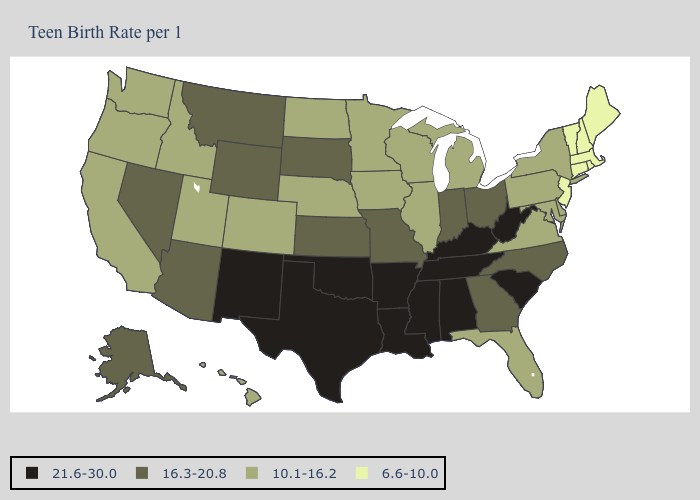What is the highest value in states that border Minnesota?
Answer briefly. 16.3-20.8. What is the value of New York?
Give a very brief answer. 10.1-16.2. Does South Carolina have the same value as Colorado?
Keep it brief. No. Does Georgia have a lower value than Indiana?
Give a very brief answer. No. What is the value of Nebraska?
Short answer required. 10.1-16.2. Among the states that border Georgia , which have the lowest value?
Answer briefly. Florida. What is the highest value in the Northeast ?
Be succinct. 10.1-16.2. What is the value of Utah?
Concise answer only. 10.1-16.2. Which states have the highest value in the USA?
Concise answer only. Alabama, Arkansas, Kentucky, Louisiana, Mississippi, New Mexico, Oklahoma, South Carolina, Tennessee, Texas, West Virginia. How many symbols are there in the legend?
Short answer required. 4. Does Washington have a higher value than New Mexico?
Answer briefly. No. Does Missouri have the highest value in the MidWest?
Quick response, please. Yes. Does Ohio have the lowest value in the USA?
Write a very short answer. No. Does Nevada have the lowest value in the West?
Write a very short answer. No. Does the first symbol in the legend represent the smallest category?
Be succinct. No. 